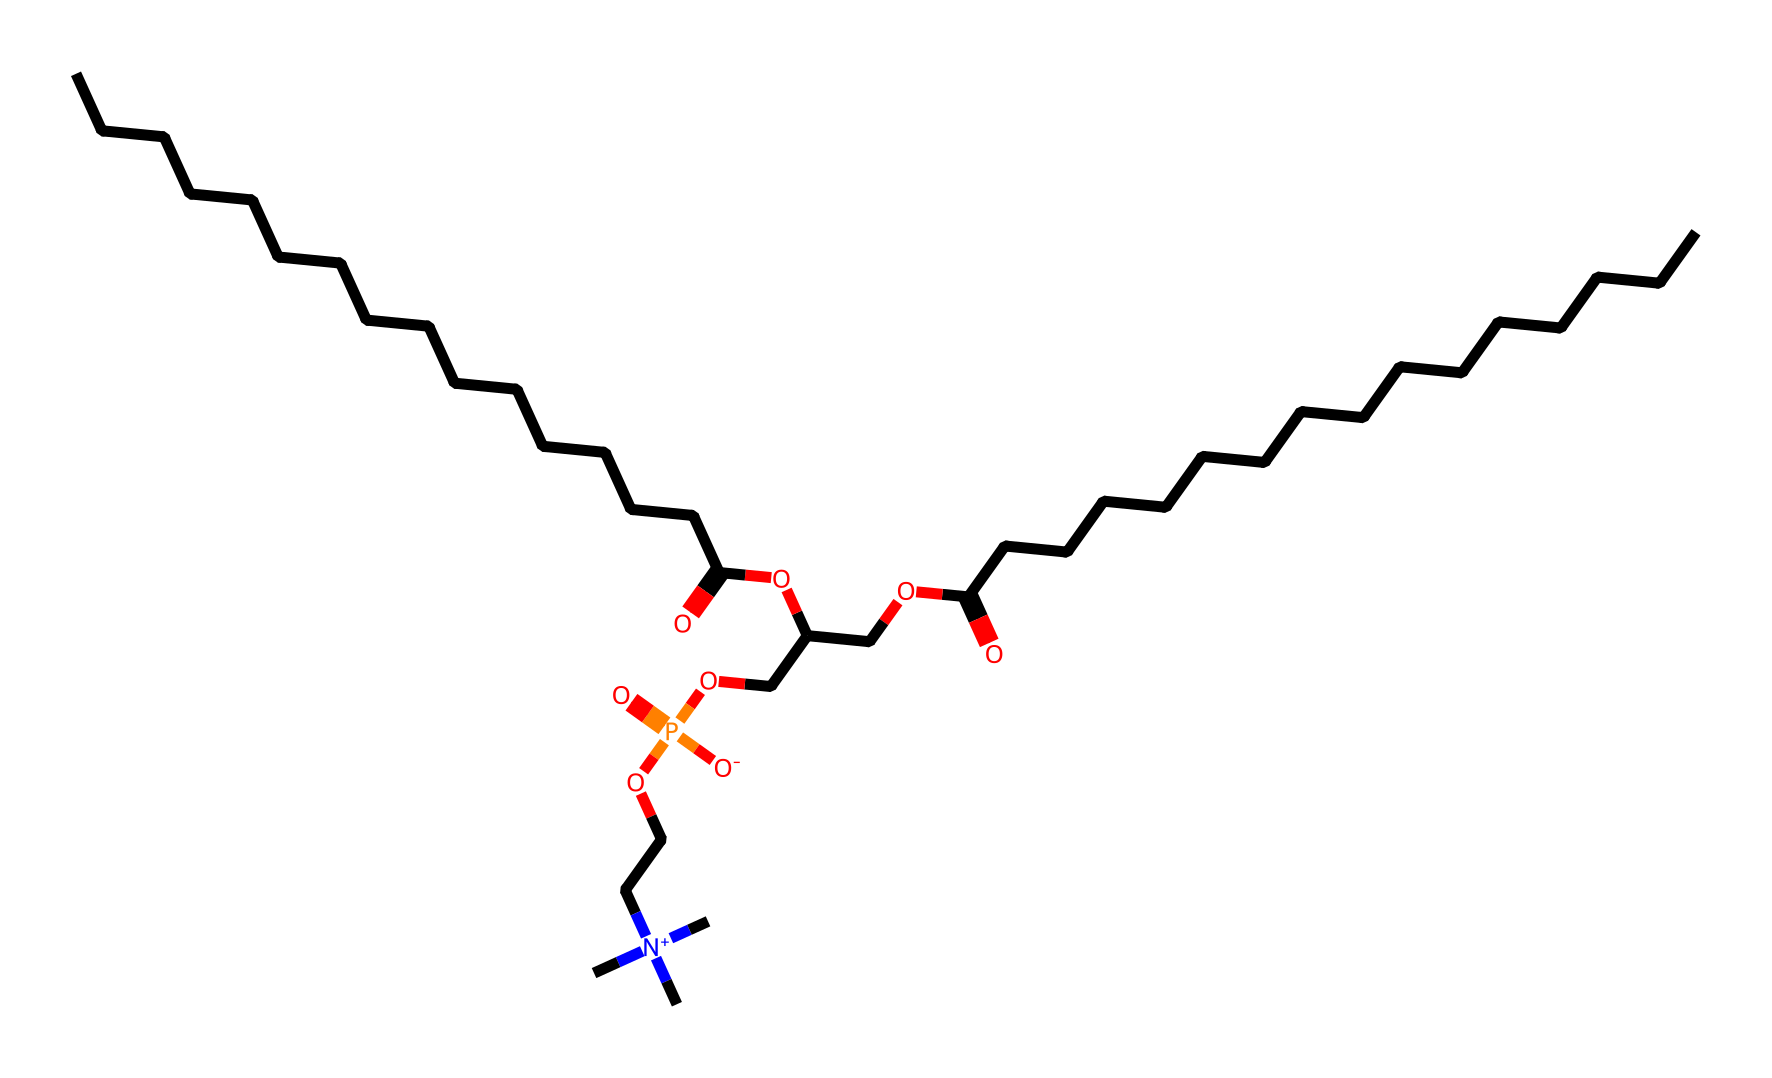What is the predominant functional group in this molecule? The molecule contains multiple functional groups, but the carboxylic acid group (–COOH) stands out prominently in the structure. This can be identified by locating the carbon atom double-bonded to an oxygen atom and single-bonded to a hydroxyl group.
Answer: carboxylic acid How many carbon atoms are present in the molecule? By counting the carbon atoms in the SMILES representation, it can be observed that there are a total of 27 carbon atoms throughout the entire structure. This includes both the long hydrocarbon chains and the carbons in functional groups.
Answer: 27 Which part of the molecule is responsible for its amphipathic nature? The amphipathic nature arises from the presence of both hydrophobic (long hydrocarbon chains) and hydrophilic (phosphate group and choline) regions in the structure. The long carbon chains are hydrophobic, while the phosphate and choline groups provide hydrophilicity.
Answer: phosphate and choline What type of lipid does this molecule represent? This molecule represents phospholipids, which are characterized by having a phosphate group in their structure. The presence of hydrophilic and hydrophobic parts indicates that it is designed to form bilayers in cell membranes.
Answer: phospholipids How is the phosphorus atom connected in this molecule? The phosphorus atom in this structure is connected to four oxygen atoms, one of which is double-bonded (as seen in the phosphate group), while the other three participate in forming ester bonds with oxygen and contribute to the hydrophilic character.
Answer: through ester bonds 